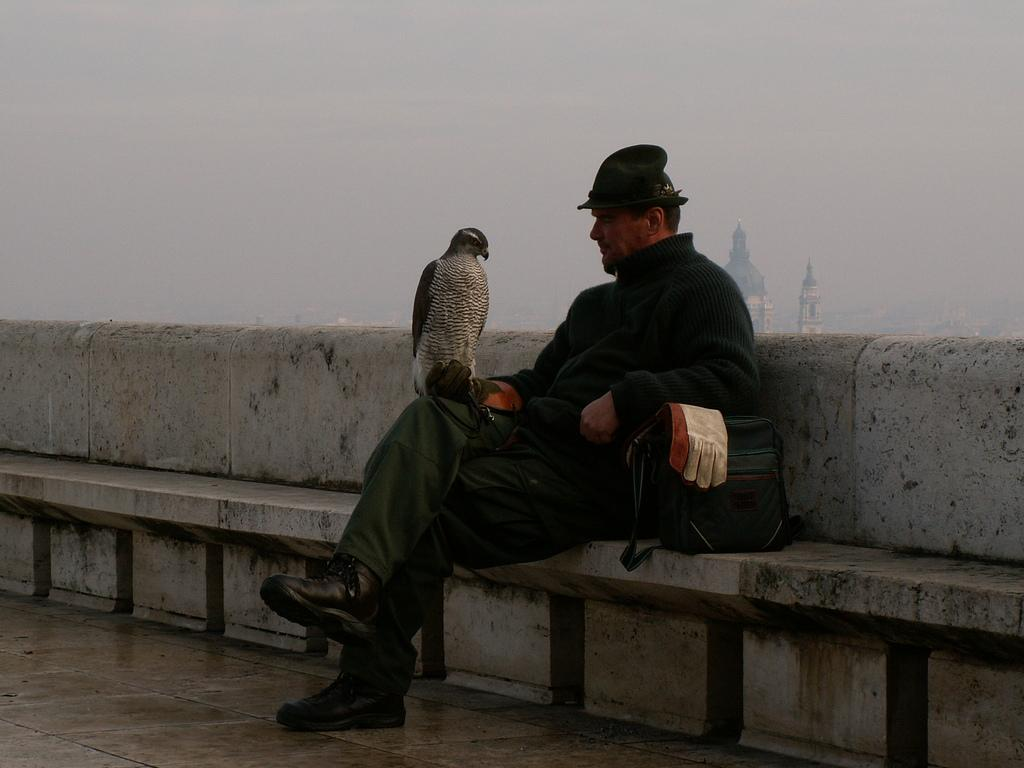What is the man in the image doing? The man is sitting in the image. What other living creature can be seen in the image? There is a bird in the image. What object is present near the man? There is a bag in the image, and a glove is on the bag. What can be seen in the distance in the image? There are buildings in the background of the image. How would you describe the weather in the image? The sky is cloudy in the image. What type of plants can be seen growing on the man's head in the image? There are no plants visible on the man's head in the image. 